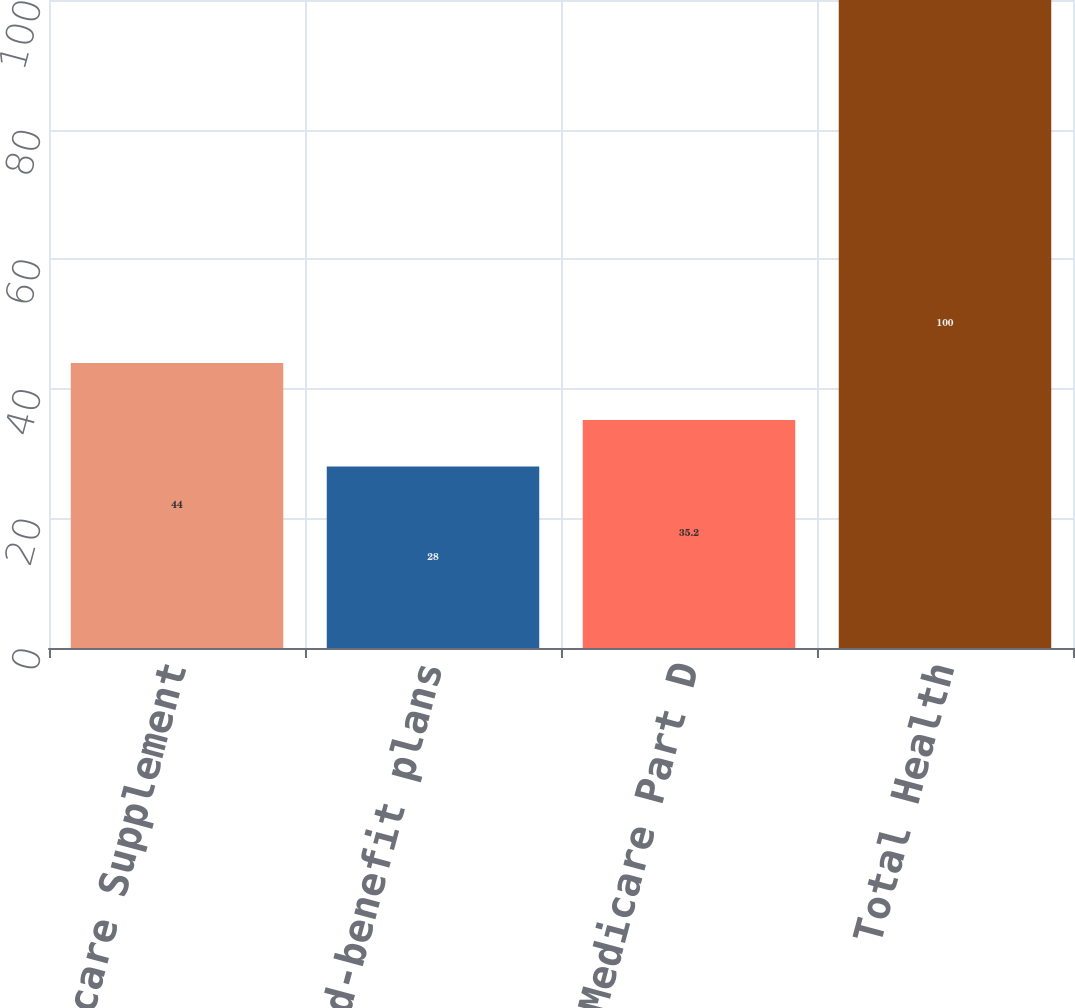Convert chart to OTSL. <chart><loc_0><loc_0><loc_500><loc_500><bar_chart><fcel>Medicare Supplement<fcel>Limited-benefit plans<fcel>Medicare Part D<fcel>Total Health<nl><fcel>44<fcel>28<fcel>35.2<fcel>100<nl></chart> 